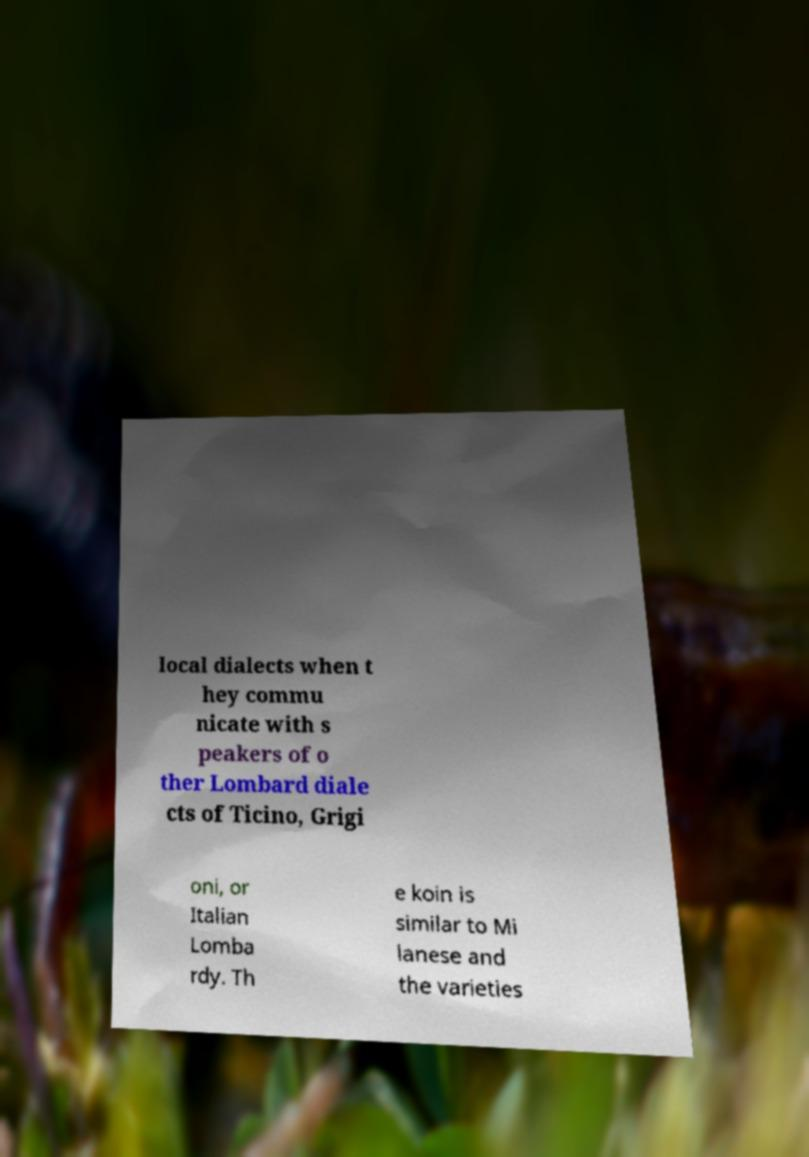What messages or text are displayed in this image? I need them in a readable, typed format. local dialects when t hey commu nicate with s peakers of o ther Lombard diale cts of Ticino, Grigi oni, or Italian Lomba rdy. Th e koin is similar to Mi lanese and the varieties 